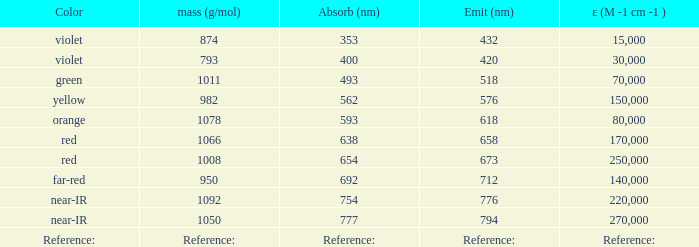Which ε (M -1 cm -1) has a molar mass of 1008 g/mol? 250000.0. 